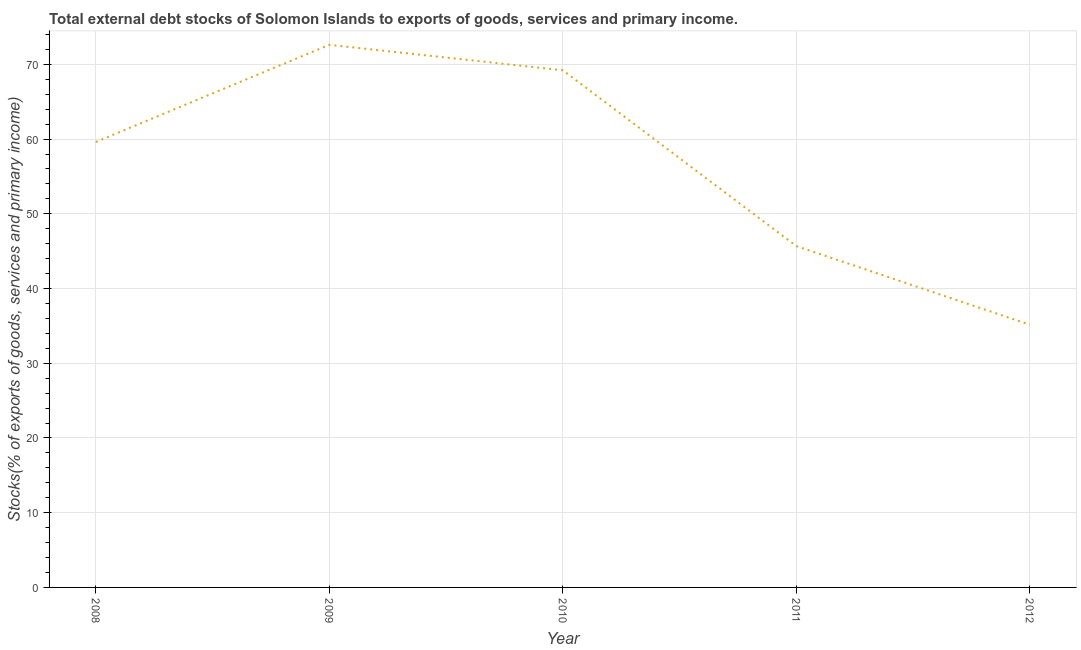What is the external debt stocks in 2011?
Give a very brief answer. 45.68. Across all years, what is the maximum external debt stocks?
Offer a terse response. 72.62. Across all years, what is the minimum external debt stocks?
Give a very brief answer. 35.16. In which year was the external debt stocks minimum?
Give a very brief answer. 2012. What is the sum of the external debt stocks?
Offer a terse response. 282.28. What is the difference between the external debt stocks in 2010 and 2011?
Ensure brevity in your answer.  23.53. What is the average external debt stocks per year?
Keep it short and to the point. 56.46. What is the median external debt stocks?
Make the answer very short. 59.61. What is the ratio of the external debt stocks in 2010 to that in 2011?
Offer a very short reply. 1.52. Is the external debt stocks in 2008 less than that in 2011?
Offer a very short reply. No. What is the difference between the highest and the second highest external debt stocks?
Provide a short and direct response. 3.4. Is the sum of the external debt stocks in 2008 and 2010 greater than the maximum external debt stocks across all years?
Provide a succinct answer. Yes. What is the difference between the highest and the lowest external debt stocks?
Your response must be concise. 37.46. Does the external debt stocks monotonically increase over the years?
Your answer should be compact. No. How many lines are there?
Offer a very short reply. 1. Are the values on the major ticks of Y-axis written in scientific E-notation?
Offer a terse response. No. What is the title of the graph?
Provide a succinct answer. Total external debt stocks of Solomon Islands to exports of goods, services and primary income. What is the label or title of the Y-axis?
Provide a short and direct response. Stocks(% of exports of goods, services and primary income). What is the Stocks(% of exports of goods, services and primary income) in 2008?
Make the answer very short. 59.61. What is the Stocks(% of exports of goods, services and primary income) in 2009?
Provide a short and direct response. 72.62. What is the Stocks(% of exports of goods, services and primary income) of 2010?
Your answer should be compact. 69.21. What is the Stocks(% of exports of goods, services and primary income) in 2011?
Keep it short and to the point. 45.68. What is the Stocks(% of exports of goods, services and primary income) in 2012?
Make the answer very short. 35.16. What is the difference between the Stocks(% of exports of goods, services and primary income) in 2008 and 2009?
Offer a terse response. -13. What is the difference between the Stocks(% of exports of goods, services and primary income) in 2008 and 2010?
Provide a short and direct response. -9.6. What is the difference between the Stocks(% of exports of goods, services and primary income) in 2008 and 2011?
Offer a terse response. 13.93. What is the difference between the Stocks(% of exports of goods, services and primary income) in 2008 and 2012?
Make the answer very short. 24.46. What is the difference between the Stocks(% of exports of goods, services and primary income) in 2009 and 2010?
Your response must be concise. 3.4. What is the difference between the Stocks(% of exports of goods, services and primary income) in 2009 and 2011?
Ensure brevity in your answer.  26.93. What is the difference between the Stocks(% of exports of goods, services and primary income) in 2009 and 2012?
Provide a succinct answer. 37.46. What is the difference between the Stocks(% of exports of goods, services and primary income) in 2010 and 2011?
Provide a succinct answer. 23.53. What is the difference between the Stocks(% of exports of goods, services and primary income) in 2010 and 2012?
Give a very brief answer. 34.05. What is the difference between the Stocks(% of exports of goods, services and primary income) in 2011 and 2012?
Provide a short and direct response. 10.52. What is the ratio of the Stocks(% of exports of goods, services and primary income) in 2008 to that in 2009?
Your answer should be very brief. 0.82. What is the ratio of the Stocks(% of exports of goods, services and primary income) in 2008 to that in 2010?
Your response must be concise. 0.86. What is the ratio of the Stocks(% of exports of goods, services and primary income) in 2008 to that in 2011?
Your response must be concise. 1.3. What is the ratio of the Stocks(% of exports of goods, services and primary income) in 2008 to that in 2012?
Your response must be concise. 1.7. What is the ratio of the Stocks(% of exports of goods, services and primary income) in 2009 to that in 2010?
Offer a very short reply. 1.05. What is the ratio of the Stocks(% of exports of goods, services and primary income) in 2009 to that in 2011?
Provide a short and direct response. 1.59. What is the ratio of the Stocks(% of exports of goods, services and primary income) in 2009 to that in 2012?
Give a very brief answer. 2.06. What is the ratio of the Stocks(% of exports of goods, services and primary income) in 2010 to that in 2011?
Offer a very short reply. 1.51. What is the ratio of the Stocks(% of exports of goods, services and primary income) in 2010 to that in 2012?
Ensure brevity in your answer.  1.97. What is the ratio of the Stocks(% of exports of goods, services and primary income) in 2011 to that in 2012?
Offer a terse response. 1.3. 